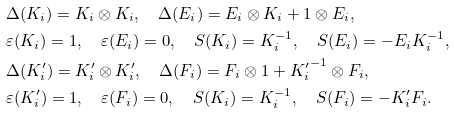Convert formula to latex. <formula><loc_0><loc_0><loc_500><loc_500>& \Delta ( K _ { i } ) = K _ { i } \otimes K _ { i } , \quad \Delta ( E _ { i } ) = E _ { i } \otimes K _ { i } + 1 \otimes E _ { i } , \\ & \varepsilon ( K _ { i } ) = 1 , \quad \varepsilon ( E _ { i } ) = 0 , \quad S ( K _ { i } ) = K _ { i } ^ { - 1 } , \quad S ( E _ { i } ) = - E _ { i } K _ { i } ^ { - 1 } , \\ & \Delta ( K ^ { \prime } _ { i } ) = K ^ { \prime } _ { i } \otimes K ^ { \prime } _ { i } , \quad \Delta ( F _ { i } ) = F _ { i } \otimes 1 + { K ^ { \prime } _ { i } } ^ { - 1 } \otimes F _ { i } , \\ & \varepsilon ( K ^ { \prime } _ { i } ) = 1 , \quad \varepsilon ( F _ { i } ) = 0 , \quad S ( K _ { i } ) = K _ { i } ^ { - 1 } , \quad S ( F _ { i } ) = - K ^ { \prime } _ { i } F _ { i } .</formula> 